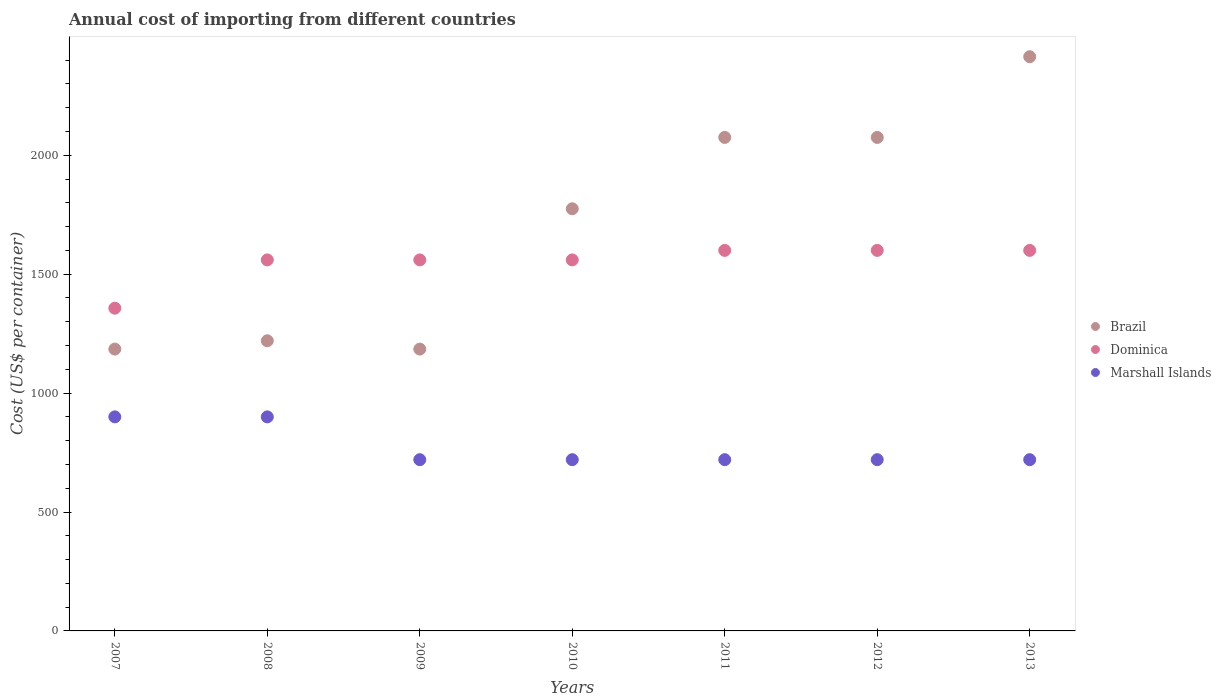What is the total annual cost of importing in Marshall Islands in 2013?
Keep it short and to the point. 720. Across all years, what is the maximum total annual cost of importing in Dominica?
Provide a short and direct response. 1600. Across all years, what is the minimum total annual cost of importing in Brazil?
Offer a terse response. 1185. In which year was the total annual cost of importing in Dominica minimum?
Your answer should be very brief. 2007. What is the total total annual cost of importing in Dominica in the graph?
Provide a short and direct response. 1.08e+04. What is the difference between the total annual cost of importing in Marshall Islands in 2011 and that in 2013?
Provide a short and direct response. 0. What is the difference between the total annual cost of importing in Brazil in 2008 and the total annual cost of importing in Marshall Islands in 2007?
Offer a very short reply. 320. What is the average total annual cost of importing in Brazil per year?
Give a very brief answer. 1704.19. In the year 2010, what is the difference between the total annual cost of importing in Brazil and total annual cost of importing in Marshall Islands?
Your answer should be very brief. 1055. In how many years, is the total annual cost of importing in Brazil greater than 1600 US$?
Keep it short and to the point. 4. What is the ratio of the total annual cost of importing in Brazil in 2011 to that in 2013?
Your answer should be very brief. 0.86. Is the difference between the total annual cost of importing in Brazil in 2007 and 2009 greater than the difference between the total annual cost of importing in Marshall Islands in 2007 and 2009?
Your answer should be very brief. No. What is the difference between the highest and the second highest total annual cost of importing in Marshall Islands?
Your answer should be compact. 0. What is the difference between the highest and the lowest total annual cost of importing in Marshall Islands?
Your answer should be compact. 180. Is the sum of the total annual cost of importing in Marshall Islands in 2008 and 2011 greater than the maximum total annual cost of importing in Brazil across all years?
Make the answer very short. No. Is it the case that in every year, the sum of the total annual cost of importing in Marshall Islands and total annual cost of importing in Dominica  is greater than the total annual cost of importing in Brazil?
Your answer should be compact. No. Does the total annual cost of importing in Dominica monotonically increase over the years?
Give a very brief answer. No. Is the total annual cost of importing in Dominica strictly greater than the total annual cost of importing in Brazil over the years?
Ensure brevity in your answer.  No. What is the difference between two consecutive major ticks on the Y-axis?
Give a very brief answer. 500. Does the graph contain any zero values?
Your answer should be very brief. No. Where does the legend appear in the graph?
Your answer should be compact. Center right. How many legend labels are there?
Offer a very short reply. 3. How are the legend labels stacked?
Make the answer very short. Vertical. What is the title of the graph?
Ensure brevity in your answer.  Annual cost of importing from different countries. What is the label or title of the Y-axis?
Make the answer very short. Cost (US$ per container). What is the Cost (US$ per container) in Brazil in 2007?
Provide a succinct answer. 1185. What is the Cost (US$ per container) of Dominica in 2007?
Make the answer very short. 1357. What is the Cost (US$ per container) in Marshall Islands in 2007?
Make the answer very short. 900. What is the Cost (US$ per container) in Brazil in 2008?
Your answer should be very brief. 1220. What is the Cost (US$ per container) in Dominica in 2008?
Give a very brief answer. 1560. What is the Cost (US$ per container) of Marshall Islands in 2008?
Your answer should be compact. 900. What is the Cost (US$ per container) in Brazil in 2009?
Offer a very short reply. 1185. What is the Cost (US$ per container) in Dominica in 2009?
Offer a very short reply. 1560. What is the Cost (US$ per container) of Marshall Islands in 2009?
Your answer should be compact. 720. What is the Cost (US$ per container) in Brazil in 2010?
Your response must be concise. 1775. What is the Cost (US$ per container) in Dominica in 2010?
Give a very brief answer. 1560. What is the Cost (US$ per container) in Marshall Islands in 2010?
Your answer should be compact. 720. What is the Cost (US$ per container) of Brazil in 2011?
Your answer should be very brief. 2075. What is the Cost (US$ per container) of Dominica in 2011?
Give a very brief answer. 1600. What is the Cost (US$ per container) in Marshall Islands in 2011?
Offer a very short reply. 720. What is the Cost (US$ per container) of Brazil in 2012?
Provide a short and direct response. 2075. What is the Cost (US$ per container) in Dominica in 2012?
Keep it short and to the point. 1600. What is the Cost (US$ per container) in Marshall Islands in 2012?
Your answer should be very brief. 720. What is the Cost (US$ per container) of Brazil in 2013?
Keep it short and to the point. 2414.3. What is the Cost (US$ per container) of Dominica in 2013?
Provide a succinct answer. 1600. What is the Cost (US$ per container) of Marshall Islands in 2013?
Offer a terse response. 720. Across all years, what is the maximum Cost (US$ per container) in Brazil?
Offer a terse response. 2414.3. Across all years, what is the maximum Cost (US$ per container) in Dominica?
Ensure brevity in your answer.  1600. Across all years, what is the maximum Cost (US$ per container) of Marshall Islands?
Keep it short and to the point. 900. Across all years, what is the minimum Cost (US$ per container) in Brazil?
Offer a terse response. 1185. Across all years, what is the minimum Cost (US$ per container) of Dominica?
Your answer should be compact. 1357. Across all years, what is the minimum Cost (US$ per container) of Marshall Islands?
Make the answer very short. 720. What is the total Cost (US$ per container) of Brazil in the graph?
Ensure brevity in your answer.  1.19e+04. What is the total Cost (US$ per container) in Dominica in the graph?
Offer a very short reply. 1.08e+04. What is the total Cost (US$ per container) in Marshall Islands in the graph?
Keep it short and to the point. 5400. What is the difference between the Cost (US$ per container) of Brazil in 2007 and that in 2008?
Keep it short and to the point. -35. What is the difference between the Cost (US$ per container) of Dominica in 2007 and that in 2008?
Keep it short and to the point. -203. What is the difference between the Cost (US$ per container) in Brazil in 2007 and that in 2009?
Give a very brief answer. 0. What is the difference between the Cost (US$ per container) in Dominica in 2007 and that in 2009?
Your response must be concise. -203. What is the difference between the Cost (US$ per container) of Marshall Islands in 2007 and that in 2009?
Offer a terse response. 180. What is the difference between the Cost (US$ per container) in Brazil in 2007 and that in 2010?
Offer a terse response. -590. What is the difference between the Cost (US$ per container) of Dominica in 2007 and that in 2010?
Offer a terse response. -203. What is the difference between the Cost (US$ per container) of Marshall Islands in 2007 and that in 2010?
Your answer should be compact. 180. What is the difference between the Cost (US$ per container) in Brazil in 2007 and that in 2011?
Provide a short and direct response. -890. What is the difference between the Cost (US$ per container) of Dominica in 2007 and that in 2011?
Ensure brevity in your answer.  -243. What is the difference between the Cost (US$ per container) of Marshall Islands in 2007 and that in 2011?
Provide a succinct answer. 180. What is the difference between the Cost (US$ per container) in Brazil in 2007 and that in 2012?
Make the answer very short. -890. What is the difference between the Cost (US$ per container) of Dominica in 2007 and that in 2012?
Make the answer very short. -243. What is the difference between the Cost (US$ per container) in Marshall Islands in 2007 and that in 2012?
Offer a terse response. 180. What is the difference between the Cost (US$ per container) in Brazil in 2007 and that in 2013?
Provide a succinct answer. -1229.3. What is the difference between the Cost (US$ per container) of Dominica in 2007 and that in 2013?
Your answer should be very brief. -243. What is the difference between the Cost (US$ per container) in Marshall Islands in 2007 and that in 2013?
Provide a short and direct response. 180. What is the difference between the Cost (US$ per container) of Marshall Islands in 2008 and that in 2009?
Give a very brief answer. 180. What is the difference between the Cost (US$ per container) in Brazil in 2008 and that in 2010?
Provide a succinct answer. -555. What is the difference between the Cost (US$ per container) of Dominica in 2008 and that in 2010?
Provide a succinct answer. 0. What is the difference between the Cost (US$ per container) of Marshall Islands in 2008 and that in 2010?
Your response must be concise. 180. What is the difference between the Cost (US$ per container) of Brazil in 2008 and that in 2011?
Give a very brief answer. -855. What is the difference between the Cost (US$ per container) of Marshall Islands in 2008 and that in 2011?
Offer a very short reply. 180. What is the difference between the Cost (US$ per container) of Brazil in 2008 and that in 2012?
Your response must be concise. -855. What is the difference between the Cost (US$ per container) in Dominica in 2008 and that in 2012?
Provide a succinct answer. -40. What is the difference between the Cost (US$ per container) of Marshall Islands in 2008 and that in 2012?
Ensure brevity in your answer.  180. What is the difference between the Cost (US$ per container) of Brazil in 2008 and that in 2013?
Provide a short and direct response. -1194.3. What is the difference between the Cost (US$ per container) in Marshall Islands in 2008 and that in 2013?
Ensure brevity in your answer.  180. What is the difference between the Cost (US$ per container) of Brazil in 2009 and that in 2010?
Offer a terse response. -590. What is the difference between the Cost (US$ per container) in Dominica in 2009 and that in 2010?
Your answer should be very brief. 0. What is the difference between the Cost (US$ per container) in Marshall Islands in 2009 and that in 2010?
Provide a short and direct response. 0. What is the difference between the Cost (US$ per container) in Brazil in 2009 and that in 2011?
Keep it short and to the point. -890. What is the difference between the Cost (US$ per container) in Marshall Islands in 2009 and that in 2011?
Offer a terse response. 0. What is the difference between the Cost (US$ per container) of Brazil in 2009 and that in 2012?
Give a very brief answer. -890. What is the difference between the Cost (US$ per container) of Brazil in 2009 and that in 2013?
Your response must be concise. -1229.3. What is the difference between the Cost (US$ per container) of Dominica in 2009 and that in 2013?
Provide a short and direct response. -40. What is the difference between the Cost (US$ per container) of Marshall Islands in 2009 and that in 2013?
Make the answer very short. 0. What is the difference between the Cost (US$ per container) in Brazil in 2010 and that in 2011?
Provide a succinct answer. -300. What is the difference between the Cost (US$ per container) in Brazil in 2010 and that in 2012?
Your answer should be compact. -300. What is the difference between the Cost (US$ per container) of Dominica in 2010 and that in 2012?
Offer a very short reply. -40. What is the difference between the Cost (US$ per container) in Brazil in 2010 and that in 2013?
Give a very brief answer. -639.3. What is the difference between the Cost (US$ per container) of Marshall Islands in 2010 and that in 2013?
Your answer should be compact. 0. What is the difference between the Cost (US$ per container) of Brazil in 2011 and that in 2012?
Provide a short and direct response. 0. What is the difference between the Cost (US$ per container) of Dominica in 2011 and that in 2012?
Give a very brief answer. 0. What is the difference between the Cost (US$ per container) of Marshall Islands in 2011 and that in 2012?
Keep it short and to the point. 0. What is the difference between the Cost (US$ per container) of Brazil in 2011 and that in 2013?
Offer a terse response. -339.3. What is the difference between the Cost (US$ per container) in Marshall Islands in 2011 and that in 2013?
Give a very brief answer. 0. What is the difference between the Cost (US$ per container) in Brazil in 2012 and that in 2013?
Your response must be concise. -339.3. What is the difference between the Cost (US$ per container) in Dominica in 2012 and that in 2013?
Make the answer very short. 0. What is the difference between the Cost (US$ per container) of Brazil in 2007 and the Cost (US$ per container) of Dominica in 2008?
Your answer should be very brief. -375. What is the difference between the Cost (US$ per container) in Brazil in 2007 and the Cost (US$ per container) in Marshall Islands in 2008?
Ensure brevity in your answer.  285. What is the difference between the Cost (US$ per container) in Dominica in 2007 and the Cost (US$ per container) in Marshall Islands in 2008?
Provide a succinct answer. 457. What is the difference between the Cost (US$ per container) of Brazil in 2007 and the Cost (US$ per container) of Dominica in 2009?
Provide a succinct answer. -375. What is the difference between the Cost (US$ per container) in Brazil in 2007 and the Cost (US$ per container) in Marshall Islands in 2009?
Give a very brief answer. 465. What is the difference between the Cost (US$ per container) in Dominica in 2007 and the Cost (US$ per container) in Marshall Islands in 2009?
Give a very brief answer. 637. What is the difference between the Cost (US$ per container) in Brazil in 2007 and the Cost (US$ per container) in Dominica in 2010?
Your answer should be compact. -375. What is the difference between the Cost (US$ per container) in Brazil in 2007 and the Cost (US$ per container) in Marshall Islands in 2010?
Make the answer very short. 465. What is the difference between the Cost (US$ per container) of Dominica in 2007 and the Cost (US$ per container) of Marshall Islands in 2010?
Offer a very short reply. 637. What is the difference between the Cost (US$ per container) of Brazil in 2007 and the Cost (US$ per container) of Dominica in 2011?
Your answer should be compact. -415. What is the difference between the Cost (US$ per container) in Brazil in 2007 and the Cost (US$ per container) in Marshall Islands in 2011?
Keep it short and to the point. 465. What is the difference between the Cost (US$ per container) of Dominica in 2007 and the Cost (US$ per container) of Marshall Islands in 2011?
Your response must be concise. 637. What is the difference between the Cost (US$ per container) of Brazil in 2007 and the Cost (US$ per container) of Dominica in 2012?
Give a very brief answer. -415. What is the difference between the Cost (US$ per container) of Brazil in 2007 and the Cost (US$ per container) of Marshall Islands in 2012?
Offer a very short reply. 465. What is the difference between the Cost (US$ per container) in Dominica in 2007 and the Cost (US$ per container) in Marshall Islands in 2012?
Provide a succinct answer. 637. What is the difference between the Cost (US$ per container) of Brazil in 2007 and the Cost (US$ per container) of Dominica in 2013?
Your response must be concise. -415. What is the difference between the Cost (US$ per container) in Brazil in 2007 and the Cost (US$ per container) in Marshall Islands in 2013?
Your answer should be compact. 465. What is the difference between the Cost (US$ per container) of Dominica in 2007 and the Cost (US$ per container) of Marshall Islands in 2013?
Offer a terse response. 637. What is the difference between the Cost (US$ per container) in Brazil in 2008 and the Cost (US$ per container) in Dominica in 2009?
Keep it short and to the point. -340. What is the difference between the Cost (US$ per container) of Brazil in 2008 and the Cost (US$ per container) of Marshall Islands in 2009?
Ensure brevity in your answer.  500. What is the difference between the Cost (US$ per container) of Dominica in 2008 and the Cost (US$ per container) of Marshall Islands in 2009?
Make the answer very short. 840. What is the difference between the Cost (US$ per container) of Brazil in 2008 and the Cost (US$ per container) of Dominica in 2010?
Provide a succinct answer. -340. What is the difference between the Cost (US$ per container) of Dominica in 2008 and the Cost (US$ per container) of Marshall Islands in 2010?
Offer a terse response. 840. What is the difference between the Cost (US$ per container) of Brazil in 2008 and the Cost (US$ per container) of Dominica in 2011?
Your response must be concise. -380. What is the difference between the Cost (US$ per container) of Brazil in 2008 and the Cost (US$ per container) of Marshall Islands in 2011?
Your response must be concise. 500. What is the difference between the Cost (US$ per container) of Dominica in 2008 and the Cost (US$ per container) of Marshall Islands in 2011?
Your answer should be compact. 840. What is the difference between the Cost (US$ per container) of Brazil in 2008 and the Cost (US$ per container) of Dominica in 2012?
Offer a terse response. -380. What is the difference between the Cost (US$ per container) of Dominica in 2008 and the Cost (US$ per container) of Marshall Islands in 2012?
Offer a very short reply. 840. What is the difference between the Cost (US$ per container) of Brazil in 2008 and the Cost (US$ per container) of Dominica in 2013?
Offer a very short reply. -380. What is the difference between the Cost (US$ per container) in Dominica in 2008 and the Cost (US$ per container) in Marshall Islands in 2013?
Your response must be concise. 840. What is the difference between the Cost (US$ per container) of Brazil in 2009 and the Cost (US$ per container) of Dominica in 2010?
Your answer should be very brief. -375. What is the difference between the Cost (US$ per container) of Brazil in 2009 and the Cost (US$ per container) of Marshall Islands in 2010?
Give a very brief answer. 465. What is the difference between the Cost (US$ per container) of Dominica in 2009 and the Cost (US$ per container) of Marshall Islands in 2010?
Make the answer very short. 840. What is the difference between the Cost (US$ per container) in Brazil in 2009 and the Cost (US$ per container) in Dominica in 2011?
Your answer should be very brief. -415. What is the difference between the Cost (US$ per container) of Brazil in 2009 and the Cost (US$ per container) of Marshall Islands in 2011?
Give a very brief answer. 465. What is the difference between the Cost (US$ per container) in Dominica in 2009 and the Cost (US$ per container) in Marshall Islands in 2011?
Offer a very short reply. 840. What is the difference between the Cost (US$ per container) of Brazil in 2009 and the Cost (US$ per container) of Dominica in 2012?
Offer a very short reply. -415. What is the difference between the Cost (US$ per container) of Brazil in 2009 and the Cost (US$ per container) of Marshall Islands in 2012?
Your answer should be compact. 465. What is the difference between the Cost (US$ per container) of Dominica in 2009 and the Cost (US$ per container) of Marshall Islands in 2012?
Provide a short and direct response. 840. What is the difference between the Cost (US$ per container) of Brazil in 2009 and the Cost (US$ per container) of Dominica in 2013?
Keep it short and to the point. -415. What is the difference between the Cost (US$ per container) in Brazil in 2009 and the Cost (US$ per container) in Marshall Islands in 2013?
Make the answer very short. 465. What is the difference between the Cost (US$ per container) in Dominica in 2009 and the Cost (US$ per container) in Marshall Islands in 2013?
Give a very brief answer. 840. What is the difference between the Cost (US$ per container) of Brazil in 2010 and the Cost (US$ per container) of Dominica in 2011?
Ensure brevity in your answer.  175. What is the difference between the Cost (US$ per container) in Brazil in 2010 and the Cost (US$ per container) in Marshall Islands in 2011?
Offer a very short reply. 1055. What is the difference between the Cost (US$ per container) of Dominica in 2010 and the Cost (US$ per container) of Marshall Islands in 2011?
Make the answer very short. 840. What is the difference between the Cost (US$ per container) of Brazil in 2010 and the Cost (US$ per container) of Dominica in 2012?
Offer a very short reply. 175. What is the difference between the Cost (US$ per container) of Brazil in 2010 and the Cost (US$ per container) of Marshall Islands in 2012?
Provide a succinct answer. 1055. What is the difference between the Cost (US$ per container) in Dominica in 2010 and the Cost (US$ per container) in Marshall Islands in 2012?
Offer a very short reply. 840. What is the difference between the Cost (US$ per container) of Brazil in 2010 and the Cost (US$ per container) of Dominica in 2013?
Give a very brief answer. 175. What is the difference between the Cost (US$ per container) of Brazil in 2010 and the Cost (US$ per container) of Marshall Islands in 2013?
Provide a short and direct response. 1055. What is the difference between the Cost (US$ per container) of Dominica in 2010 and the Cost (US$ per container) of Marshall Islands in 2013?
Offer a terse response. 840. What is the difference between the Cost (US$ per container) of Brazil in 2011 and the Cost (US$ per container) of Dominica in 2012?
Provide a succinct answer. 475. What is the difference between the Cost (US$ per container) in Brazil in 2011 and the Cost (US$ per container) in Marshall Islands in 2012?
Give a very brief answer. 1355. What is the difference between the Cost (US$ per container) of Dominica in 2011 and the Cost (US$ per container) of Marshall Islands in 2012?
Provide a succinct answer. 880. What is the difference between the Cost (US$ per container) of Brazil in 2011 and the Cost (US$ per container) of Dominica in 2013?
Offer a terse response. 475. What is the difference between the Cost (US$ per container) of Brazil in 2011 and the Cost (US$ per container) of Marshall Islands in 2013?
Provide a short and direct response. 1355. What is the difference between the Cost (US$ per container) in Dominica in 2011 and the Cost (US$ per container) in Marshall Islands in 2013?
Ensure brevity in your answer.  880. What is the difference between the Cost (US$ per container) in Brazil in 2012 and the Cost (US$ per container) in Dominica in 2013?
Your response must be concise. 475. What is the difference between the Cost (US$ per container) of Brazil in 2012 and the Cost (US$ per container) of Marshall Islands in 2013?
Your response must be concise. 1355. What is the difference between the Cost (US$ per container) of Dominica in 2012 and the Cost (US$ per container) of Marshall Islands in 2013?
Your response must be concise. 880. What is the average Cost (US$ per container) of Brazil per year?
Your answer should be very brief. 1704.19. What is the average Cost (US$ per container) of Dominica per year?
Ensure brevity in your answer.  1548.14. What is the average Cost (US$ per container) in Marshall Islands per year?
Give a very brief answer. 771.43. In the year 2007, what is the difference between the Cost (US$ per container) in Brazil and Cost (US$ per container) in Dominica?
Provide a succinct answer. -172. In the year 2007, what is the difference between the Cost (US$ per container) of Brazil and Cost (US$ per container) of Marshall Islands?
Provide a succinct answer. 285. In the year 2007, what is the difference between the Cost (US$ per container) of Dominica and Cost (US$ per container) of Marshall Islands?
Offer a terse response. 457. In the year 2008, what is the difference between the Cost (US$ per container) in Brazil and Cost (US$ per container) in Dominica?
Your answer should be very brief. -340. In the year 2008, what is the difference between the Cost (US$ per container) of Brazil and Cost (US$ per container) of Marshall Islands?
Your answer should be compact. 320. In the year 2008, what is the difference between the Cost (US$ per container) of Dominica and Cost (US$ per container) of Marshall Islands?
Keep it short and to the point. 660. In the year 2009, what is the difference between the Cost (US$ per container) in Brazil and Cost (US$ per container) in Dominica?
Your response must be concise. -375. In the year 2009, what is the difference between the Cost (US$ per container) in Brazil and Cost (US$ per container) in Marshall Islands?
Provide a short and direct response. 465. In the year 2009, what is the difference between the Cost (US$ per container) in Dominica and Cost (US$ per container) in Marshall Islands?
Your answer should be very brief. 840. In the year 2010, what is the difference between the Cost (US$ per container) in Brazil and Cost (US$ per container) in Dominica?
Keep it short and to the point. 215. In the year 2010, what is the difference between the Cost (US$ per container) of Brazil and Cost (US$ per container) of Marshall Islands?
Keep it short and to the point. 1055. In the year 2010, what is the difference between the Cost (US$ per container) in Dominica and Cost (US$ per container) in Marshall Islands?
Provide a short and direct response. 840. In the year 2011, what is the difference between the Cost (US$ per container) of Brazil and Cost (US$ per container) of Dominica?
Offer a very short reply. 475. In the year 2011, what is the difference between the Cost (US$ per container) in Brazil and Cost (US$ per container) in Marshall Islands?
Provide a short and direct response. 1355. In the year 2011, what is the difference between the Cost (US$ per container) of Dominica and Cost (US$ per container) of Marshall Islands?
Offer a terse response. 880. In the year 2012, what is the difference between the Cost (US$ per container) in Brazil and Cost (US$ per container) in Dominica?
Your answer should be compact. 475. In the year 2012, what is the difference between the Cost (US$ per container) in Brazil and Cost (US$ per container) in Marshall Islands?
Ensure brevity in your answer.  1355. In the year 2012, what is the difference between the Cost (US$ per container) in Dominica and Cost (US$ per container) in Marshall Islands?
Your response must be concise. 880. In the year 2013, what is the difference between the Cost (US$ per container) of Brazil and Cost (US$ per container) of Dominica?
Your answer should be very brief. 814.3. In the year 2013, what is the difference between the Cost (US$ per container) of Brazil and Cost (US$ per container) of Marshall Islands?
Ensure brevity in your answer.  1694.3. In the year 2013, what is the difference between the Cost (US$ per container) of Dominica and Cost (US$ per container) of Marshall Islands?
Keep it short and to the point. 880. What is the ratio of the Cost (US$ per container) in Brazil in 2007 to that in 2008?
Offer a terse response. 0.97. What is the ratio of the Cost (US$ per container) in Dominica in 2007 to that in 2008?
Offer a very short reply. 0.87. What is the ratio of the Cost (US$ per container) of Marshall Islands in 2007 to that in 2008?
Ensure brevity in your answer.  1. What is the ratio of the Cost (US$ per container) in Brazil in 2007 to that in 2009?
Offer a very short reply. 1. What is the ratio of the Cost (US$ per container) in Dominica in 2007 to that in 2009?
Your answer should be very brief. 0.87. What is the ratio of the Cost (US$ per container) of Marshall Islands in 2007 to that in 2009?
Provide a succinct answer. 1.25. What is the ratio of the Cost (US$ per container) of Brazil in 2007 to that in 2010?
Give a very brief answer. 0.67. What is the ratio of the Cost (US$ per container) in Dominica in 2007 to that in 2010?
Keep it short and to the point. 0.87. What is the ratio of the Cost (US$ per container) of Marshall Islands in 2007 to that in 2010?
Offer a terse response. 1.25. What is the ratio of the Cost (US$ per container) of Brazil in 2007 to that in 2011?
Your answer should be compact. 0.57. What is the ratio of the Cost (US$ per container) in Dominica in 2007 to that in 2011?
Keep it short and to the point. 0.85. What is the ratio of the Cost (US$ per container) of Marshall Islands in 2007 to that in 2011?
Ensure brevity in your answer.  1.25. What is the ratio of the Cost (US$ per container) in Brazil in 2007 to that in 2012?
Offer a very short reply. 0.57. What is the ratio of the Cost (US$ per container) of Dominica in 2007 to that in 2012?
Your response must be concise. 0.85. What is the ratio of the Cost (US$ per container) in Brazil in 2007 to that in 2013?
Offer a terse response. 0.49. What is the ratio of the Cost (US$ per container) of Dominica in 2007 to that in 2013?
Give a very brief answer. 0.85. What is the ratio of the Cost (US$ per container) in Marshall Islands in 2007 to that in 2013?
Offer a terse response. 1.25. What is the ratio of the Cost (US$ per container) of Brazil in 2008 to that in 2009?
Your answer should be very brief. 1.03. What is the ratio of the Cost (US$ per container) in Brazil in 2008 to that in 2010?
Keep it short and to the point. 0.69. What is the ratio of the Cost (US$ per container) in Brazil in 2008 to that in 2011?
Ensure brevity in your answer.  0.59. What is the ratio of the Cost (US$ per container) of Brazil in 2008 to that in 2012?
Your answer should be compact. 0.59. What is the ratio of the Cost (US$ per container) in Brazil in 2008 to that in 2013?
Ensure brevity in your answer.  0.51. What is the ratio of the Cost (US$ per container) of Dominica in 2008 to that in 2013?
Ensure brevity in your answer.  0.97. What is the ratio of the Cost (US$ per container) in Brazil in 2009 to that in 2010?
Provide a succinct answer. 0.67. What is the ratio of the Cost (US$ per container) of Dominica in 2009 to that in 2010?
Provide a succinct answer. 1. What is the ratio of the Cost (US$ per container) of Marshall Islands in 2009 to that in 2010?
Your answer should be compact. 1. What is the ratio of the Cost (US$ per container) in Brazil in 2009 to that in 2011?
Ensure brevity in your answer.  0.57. What is the ratio of the Cost (US$ per container) in Dominica in 2009 to that in 2011?
Your answer should be compact. 0.97. What is the ratio of the Cost (US$ per container) of Brazil in 2009 to that in 2012?
Offer a very short reply. 0.57. What is the ratio of the Cost (US$ per container) of Dominica in 2009 to that in 2012?
Provide a succinct answer. 0.97. What is the ratio of the Cost (US$ per container) in Brazil in 2009 to that in 2013?
Keep it short and to the point. 0.49. What is the ratio of the Cost (US$ per container) in Marshall Islands in 2009 to that in 2013?
Give a very brief answer. 1. What is the ratio of the Cost (US$ per container) of Brazil in 2010 to that in 2011?
Your response must be concise. 0.86. What is the ratio of the Cost (US$ per container) of Brazil in 2010 to that in 2012?
Provide a succinct answer. 0.86. What is the ratio of the Cost (US$ per container) in Brazil in 2010 to that in 2013?
Provide a succinct answer. 0.74. What is the ratio of the Cost (US$ per container) in Marshall Islands in 2010 to that in 2013?
Give a very brief answer. 1. What is the ratio of the Cost (US$ per container) in Dominica in 2011 to that in 2012?
Offer a very short reply. 1. What is the ratio of the Cost (US$ per container) in Marshall Islands in 2011 to that in 2012?
Your answer should be compact. 1. What is the ratio of the Cost (US$ per container) of Brazil in 2011 to that in 2013?
Provide a short and direct response. 0.86. What is the ratio of the Cost (US$ per container) of Dominica in 2011 to that in 2013?
Give a very brief answer. 1. What is the ratio of the Cost (US$ per container) of Brazil in 2012 to that in 2013?
Provide a succinct answer. 0.86. What is the ratio of the Cost (US$ per container) of Marshall Islands in 2012 to that in 2013?
Ensure brevity in your answer.  1. What is the difference between the highest and the second highest Cost (US$ per container) in Brazil?
Your answer should be compact. 339.3. What is the difference between the highest and the lowest Cost (US$ per container) in Brazil?
Provide a succinct answer. 1229.3. What is the difference between the highest and the lowest Cost (US$ per container) of Dominica?
Offer a very short reply. 243. What is the difference between the highest and the lowest Cost (US$ per container) of Marshall Islands?
Your answer should be compact. 180. 